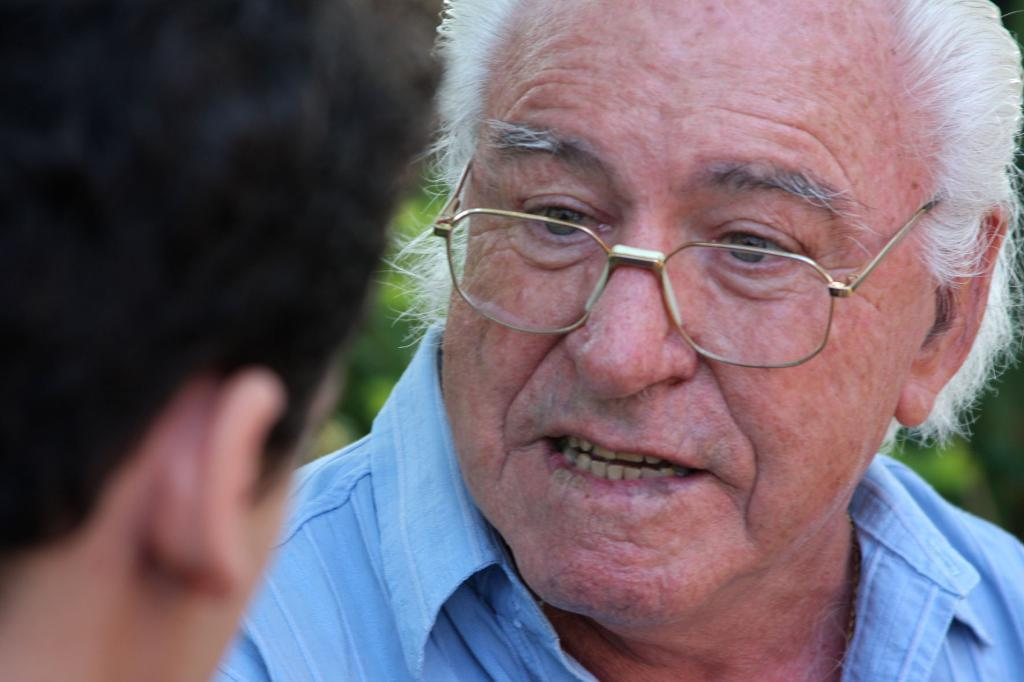What is the person in the image wearing on their face? The person in the image is wearing spectacles. Who is the person in the image looking at? The person is looking at another person. Can you describe the background of the image? The background of the image is blurred. What type of vessel is being used to provide shade in the image? There is no vessel or shade present in the image. Is there a lamp visible in the image? There is no lamp visible in the image. 